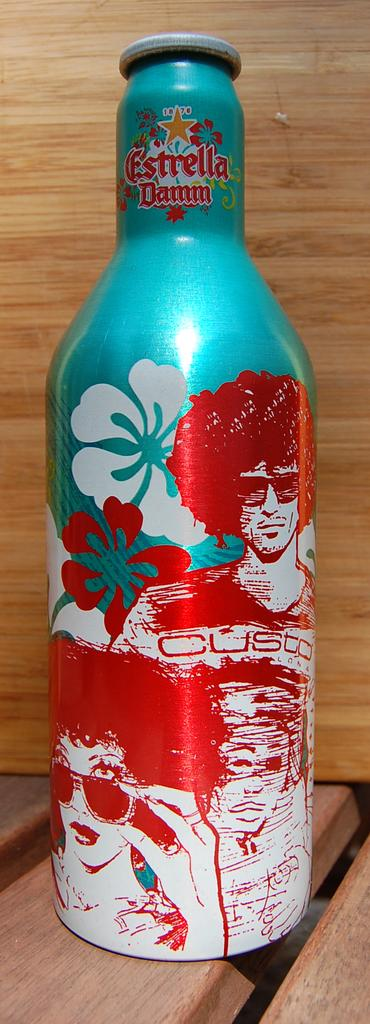<image>
Render a clear and concise summary of the photo. A bottle of Estrella with green and red designs is on a wooden table. 